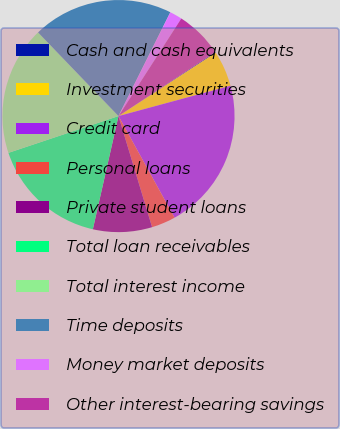Convert chart to OTSL. <chart><loc_0><loc_0><loc_500><loc_500><pie_chart><fcel>Cash and cash equivalents<fcel>Investment securities<fcel>Credit card<fcel>Personal loans<fcel>Private student loans<fcel>Total loan receivables<fcel>Total interest income<fcel>Time deposits<fcel>Money market deposits<fcel>Other interest-bearing savings<nl><fcel>0.11%<fcel>4.98%<fcel>21.18%<fcel>3.35%<fcel>8.22%<fcel>16.32%<fcel>17.94%<fcel>19.56%<fcel>1.73%<fcel>6.6%<nl></chart> 